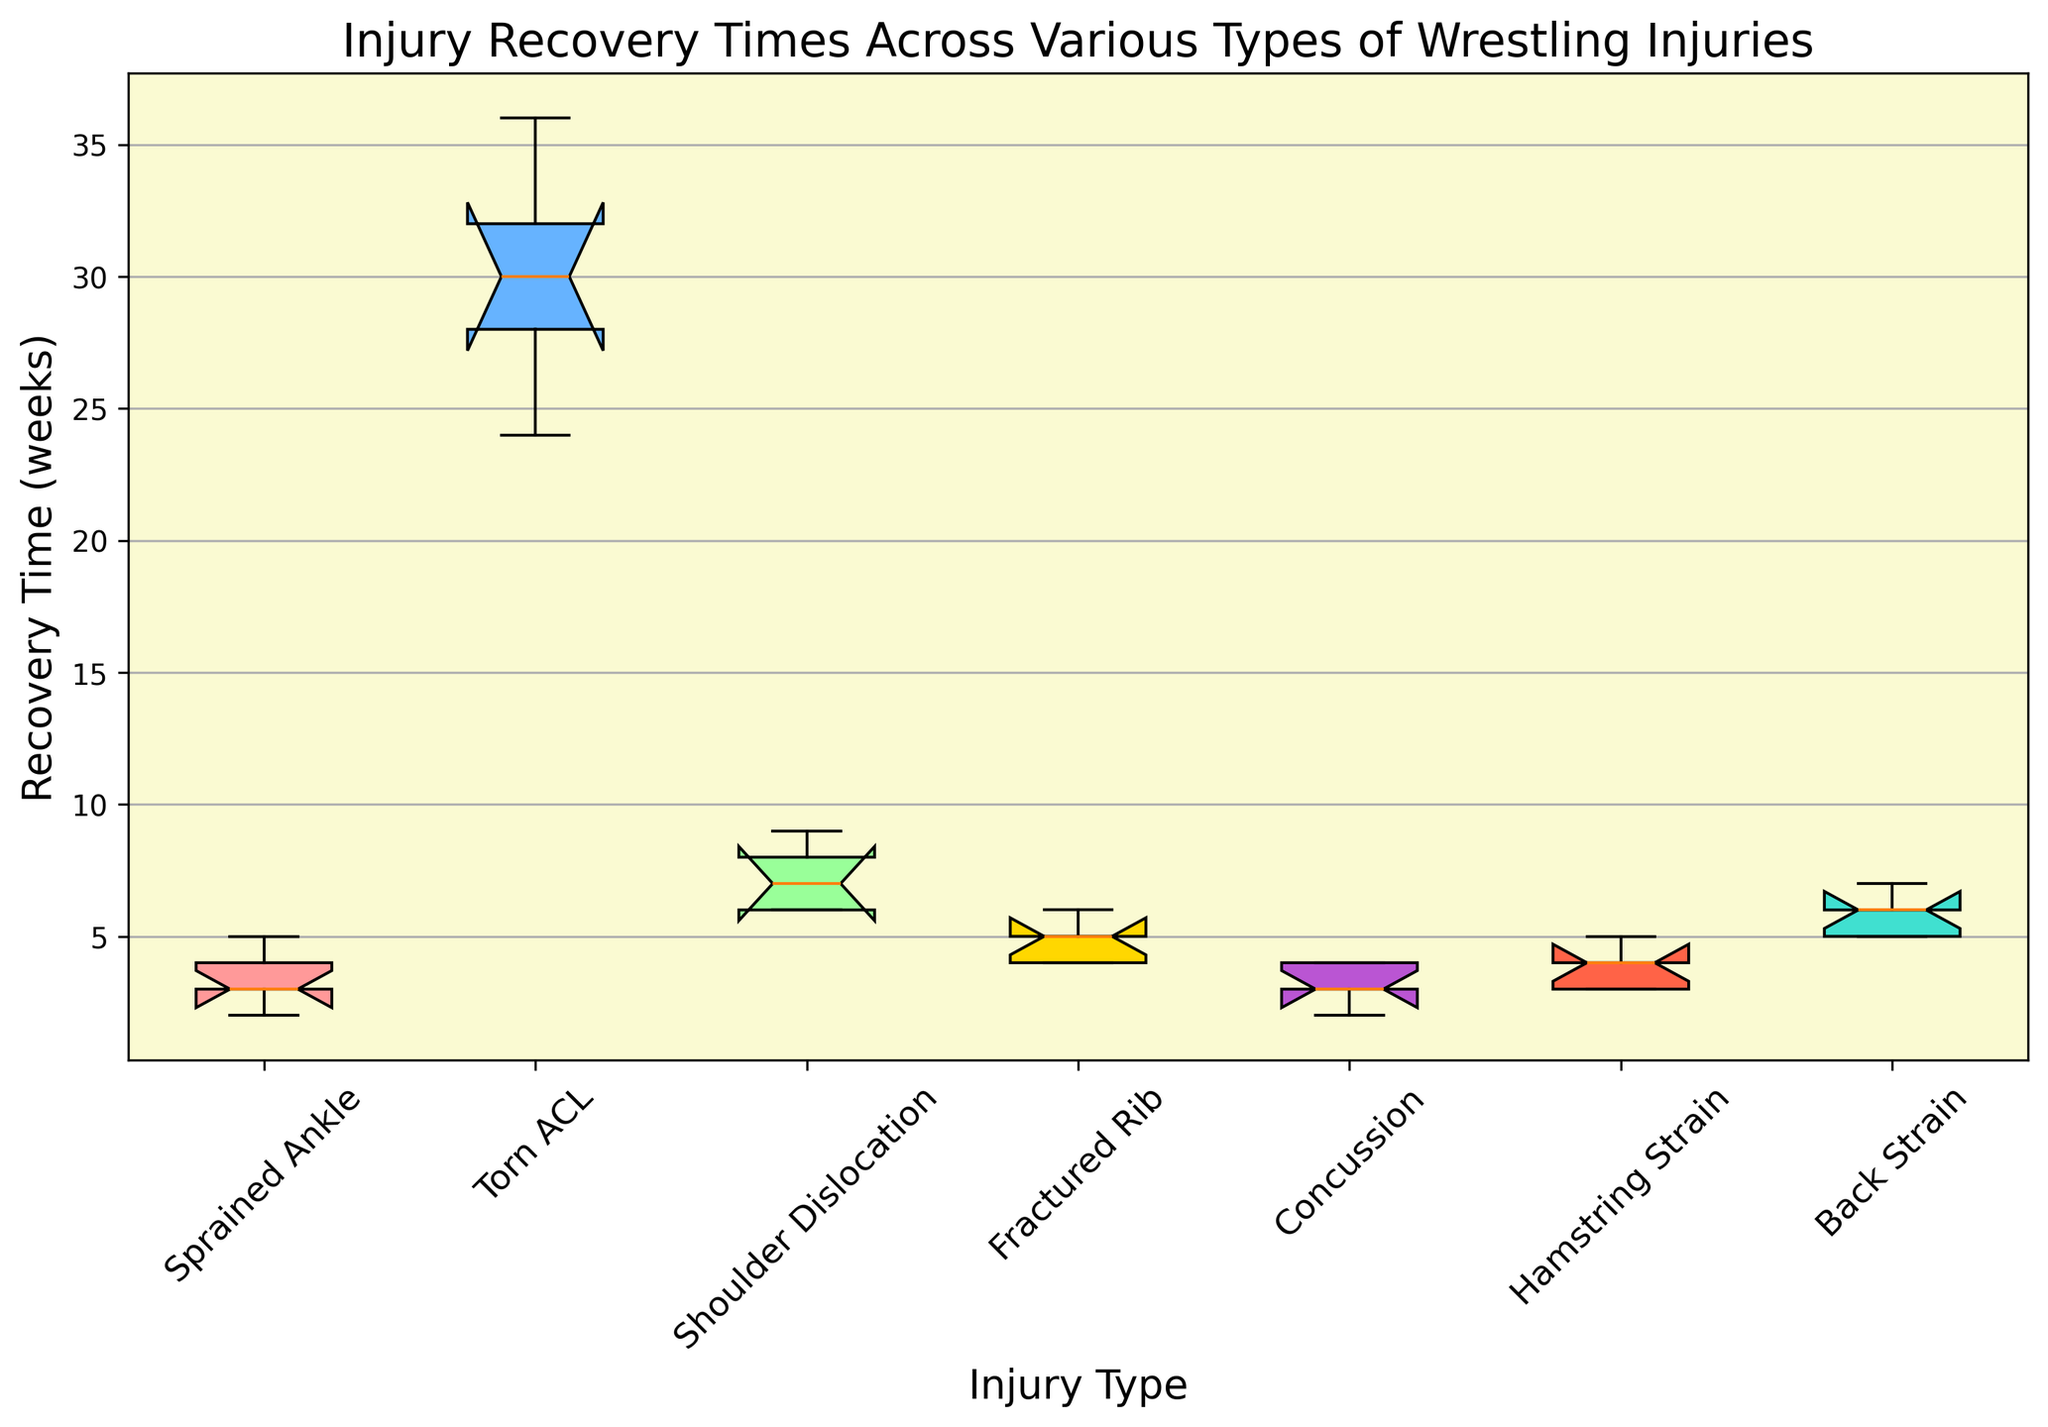What is the median recovery time for a sprained ankle? To find the median recovery time, look at the box plot and locate the central line within the box for the "Sprained Ankle" category. This line represents the median.
Answer: 3 weeks Which injury has the longest median recovery time? To determine the longest median recovery time, compare the central lines within the boxes of each injury type. The taller central line indicates a longer median recovery time.
Answer: Torn ACL Between a shoulder dislocation and a hamstring strain, which has a wider range of recovery times? The range is indicated by the length of the box and the whiskers. Compare the lengths of the boxes and whiskers for "Shoulder Dislocation" and "Hamstring Strain."
Answer: Shoulder Dislocation By how many weeks is the upper quartile of recovery time for a torn ACL greater than that of a back strain? The upper quartile is the top edge of the box. Measure the difference between the top edges of the "Torn ACL" and "Back Strain" boxes.
Answer: 25 weeks What is the interquartile range (IQR) for fractured ribs? The IQR is the difference between the upper and lower quartile (top and bottom edges of the box). Calculate this difference for "Fractured Rib."
Answer: 1 week Which injury type has the smallest variance in recovery times? Variance in recovery times is indicated by the spread of the box and whiskers. The smallest box and shortest whiskers suggest the smallest variance.
Answer: Hamstring Strain Is the median recovery time for a concussion less than the lower quartile for a shoulder dislocation? Compare the central line (median) of the "Concussion" box with the bottom edge (lower quartile) of the "Shoulder Dislocation" box.
Answer: Yes How many weeks longer is the median recovery time for a torn ACL compared to a sprained ankle? Find the difference between the central lines (medians) of the "Torn ACL" and "Sprained Ankle" boxes.
Answer: 24 weeks Which injury has the highest maximum recovery time? The maximum recovery time is indicated by the top whisker. Find the tallest top whisker among all injury types.
Answer: Torn ACL Compare the recovery times between a concussion and a sprained ankle. Which has a greater variability in recovery time? Variability is shown by the length of the box and whiskers. Compare these lengths between "Concussion" and "Sprained Ankle."
Answer: Sprained Ankle 